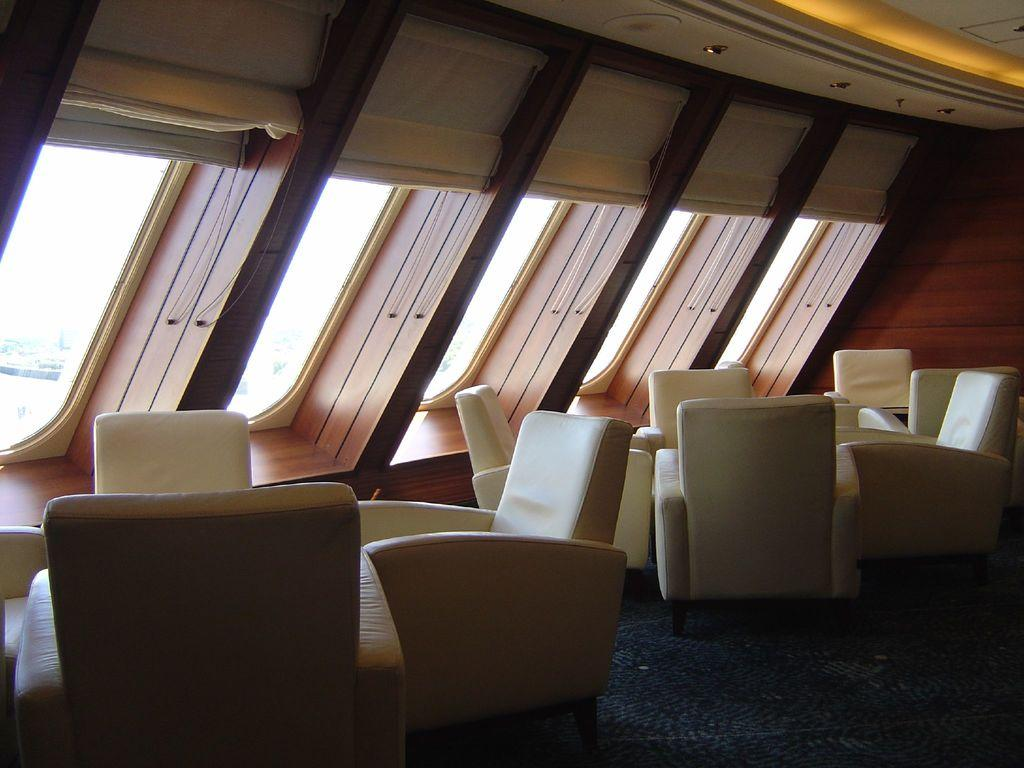What type of furniture is present in the image? There are sofas in the image. Are the sofas occupied or empty? The sofas are empty in the image. What can be seen through the windows in the image? The facts provided do not specify what can be seen through the windows. What type of stem can be seen growing from the monkey in the image? There is no monkey present in the image, and therefore no stem can be associated with it. 